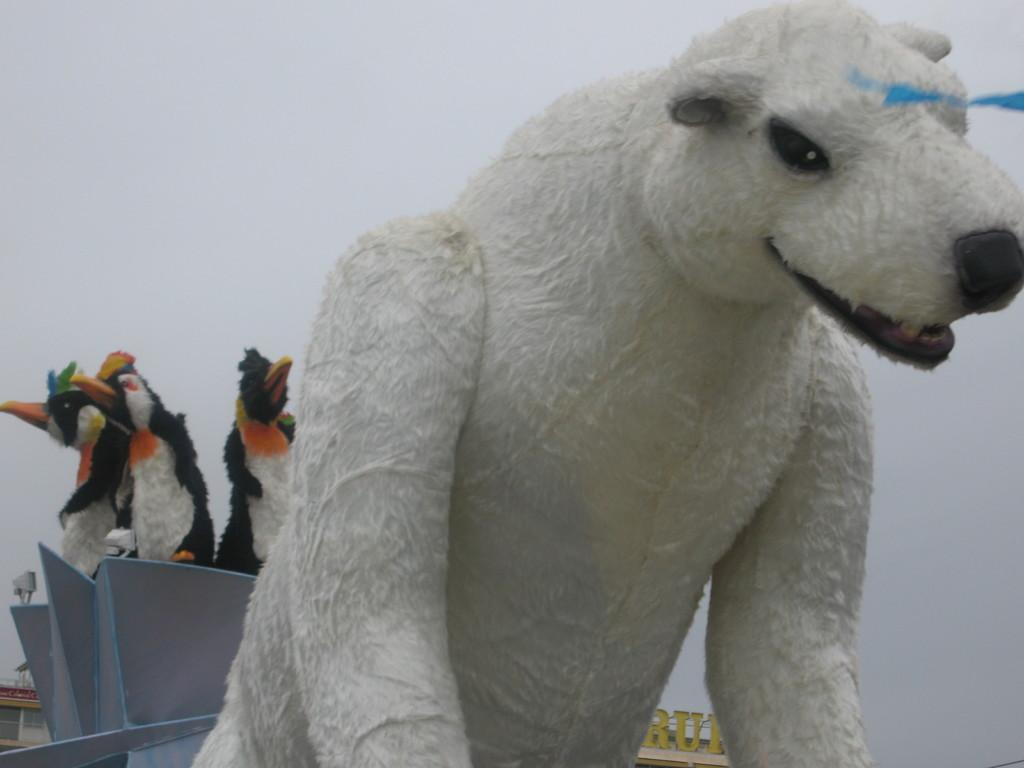What type of animal is in the image? The animal in the image is a penguin. What material is present in the image? There is glass in the image. Can you describe any other objects in the image besides the penguin and glass? Yes, there are other objects in the image. What can be seen in the background of the image? The sky is visible in the background of the image. What type of calculator is being used by the penguin in the image? There is no calculator present in the image; it features a penguin and other objects. Can you describe the spot where the penguin is standing in the image? There is no specific spot mentioned in the image; it only shows a penguin and other objects. 